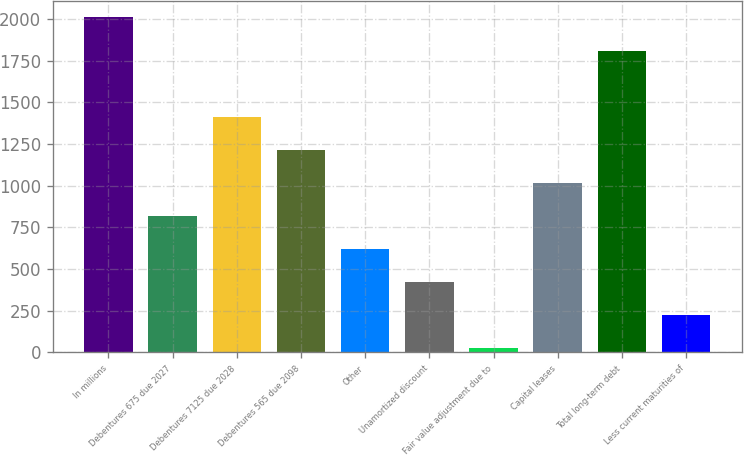<chart> <loc_0><loc_0><loc_500><loc_500><bar_chart><fcel>In millions<fcel>Debentures 675 due 2027<fcel>Debentures 7125 due 2028<fcel>Debentures 565 due 2098<fcel>Other<fcel>Unamortized discount<fcel>Fair value adjustment due to<fcel>Capital leases<fcel>Total long-term debt<fcel>Less current maturities of<nl><fcel>2009<fcel>818.6<fcel>1413.8<fcel>1215.4<fcel>620.2<fcel>421.8<fcel>25<fcel>1017<fcel>1810.6<fcel>223.4<nl></chart> 